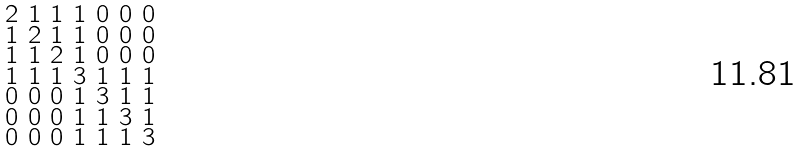Convert formula to latex. <formula><loc_0><loc_0><loc_500><loc_500>\begin{smallmatrix} 2 & 1 & 1 & 1 & 0 & 0 & 0 \\ 1 & 2 & 1 & 1 & 0 & 0 & 0 \\ 1 & 1 & 2 & 1 & 0 & 0 & 0 \\ 1 & 1 & 1 & 3 & 1 & 1 & 1 \\ 0 & 0 & 0 & 1 & 3 & 1 & 1 \\ 0 & 0 & 0 & 1 & 1 & 3 & 1 \\ 0 & 0 & 0 & 1 & 1 & 1 & 3 \end{smallmatrix}</formula> 